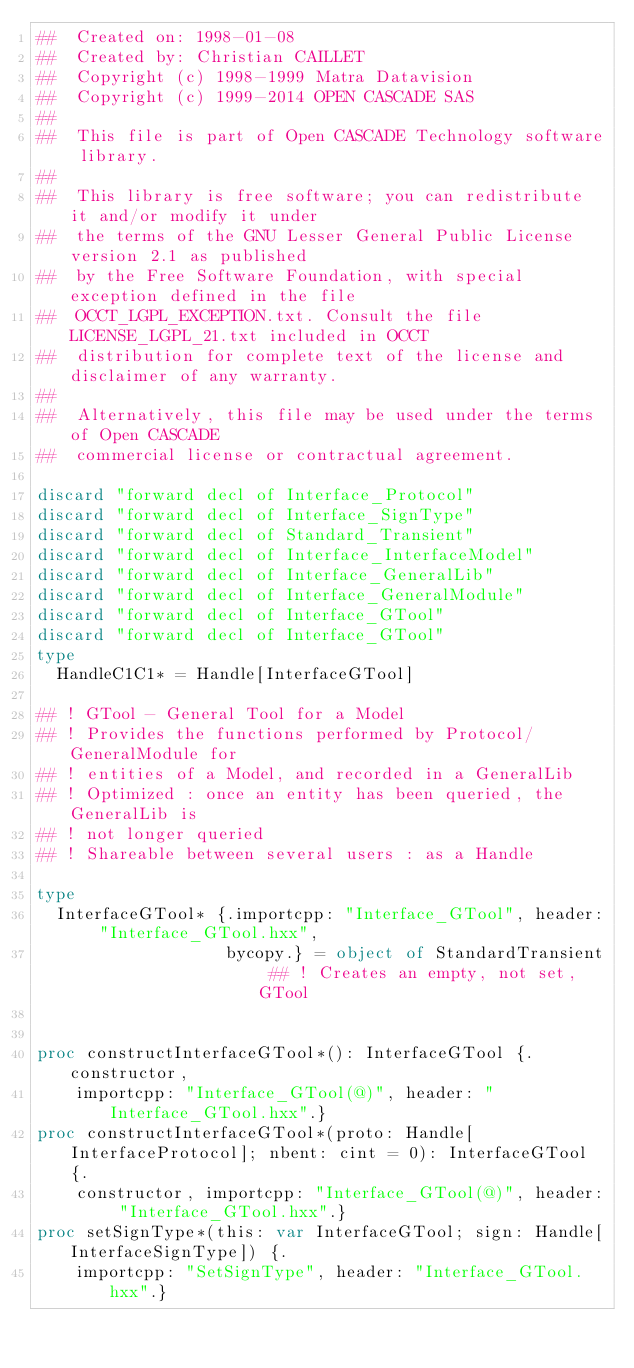<code> <loc_0><loc_0><loc_500><loc_500><_Nim_>##  Created on: 1998-01-08
##  Created by: Christian CAILLET
##  Copyright (c) 1998-1999 Matra Datavision
##  Copyright (c) 1999-2014 OPEN CASCADE SAS
##
##  This file is part of Open CASCADE Technology software library.
##
##  This library is free software; you can redistribute it and/or modify it under
##  the terms of the GNU Lesser General Public License version 2.1 as published
##  by the Free Software Foundation, with special exception defined in the file
##  OCCT_LGPL_EXCEPTION.txt. Consult the file LICENSE_LGPL_21.txt included in OCCT
##  distribution for complete text of the license and disclaimer of any warranty.
##
##  Alternatively, this file may be used under the terms of Open CASCADE
##  commercial license or contractual agreement.

discard "forward decl of Interface_Protocol"
discard "forward decl of Interface_SignType"
discard "forward decl of Standard_Transient"
discard "forward decl of Interface_InterfaceModel"
discard "forward decl of Interface_GeneralLib"
discard "forward decl of Interface_GeneralModule"
discard "forward decl of Interface_GTool"
discard "forward decl of Interface_GTool"
type
  HandleC1C1* = Handle[InterfaceGTool]

## ! GTool - General Tool for a Model
## ! Provides the functions performed by Protocol/GeneralModule for
## ! entities of a Model, and recorded in a GeneralLib
## ! Optimized : once an entity has been queried, the GeneralLib is
## ! not longer queried
## ! Shareable between several users : as a Handle

type
  InterfaceGTool* {.importcpp: "Interface_GTool", header: "Interface_GTool.hxx",
                   bycopy.} = object of StandardTransient ## ! Creates an empty, not set, GTool


proc constructInterfaceGTool*(): InterfaceGTool {.constructor,
    importcpp: "Interface_GTool(@)", header: "Interface_GTool.hxx".}
proc constructInterfaceGTool*(proto: Handle[InterfaceProtocol]; nbent: cint = 0): InterfaceGTool {.
    constructor, importcpp: "Interface_GTool(@)", header: "Interface_GTool.hxx".}
proc setSignType*(this: var InterfaceGTool; sign: Handle[InterfaceSignType]) {.
    importcpp: "SetSignType", header: "Interface_GTool.hxx".}</code> 